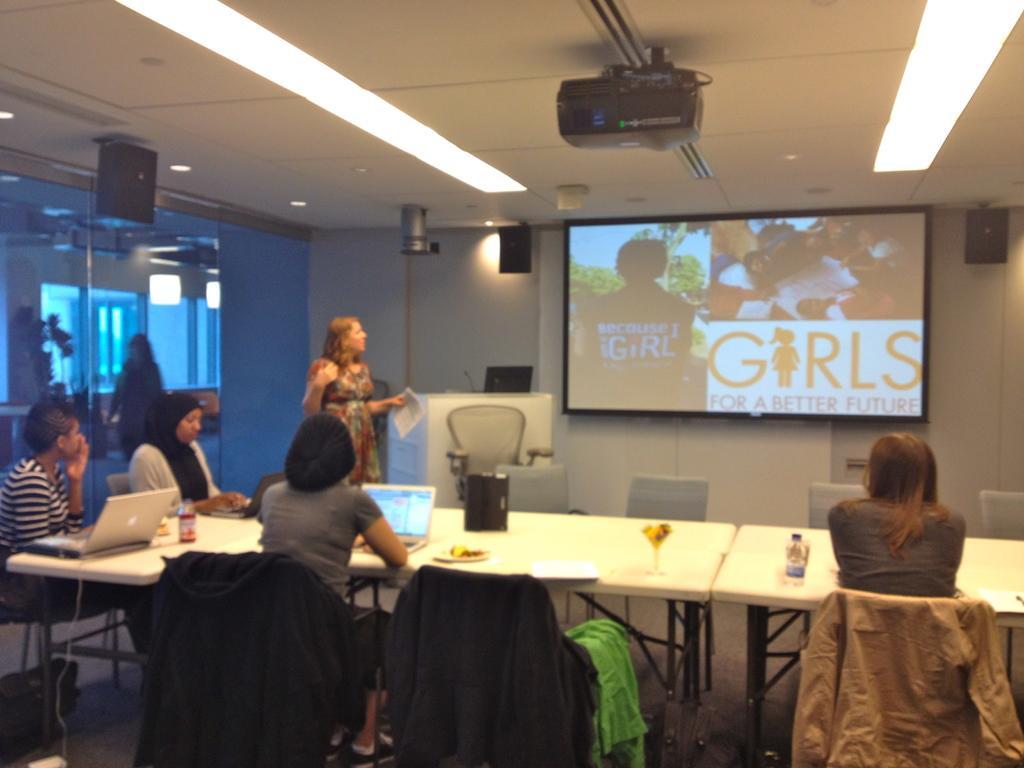Describe this image in one or two sentences. In this picture there are for ladies sitting on the chair. In front of them there is a table with laptop, glass, plate and a bottle on it. To the left there is a lady standing and holding a paper in her hand. In the middle there is a screen. Beside the screen there is a podium with mic and laptop on it. In front of the podium there is a chair. And on the top there is a projector. In the three corners there are three speakers. 